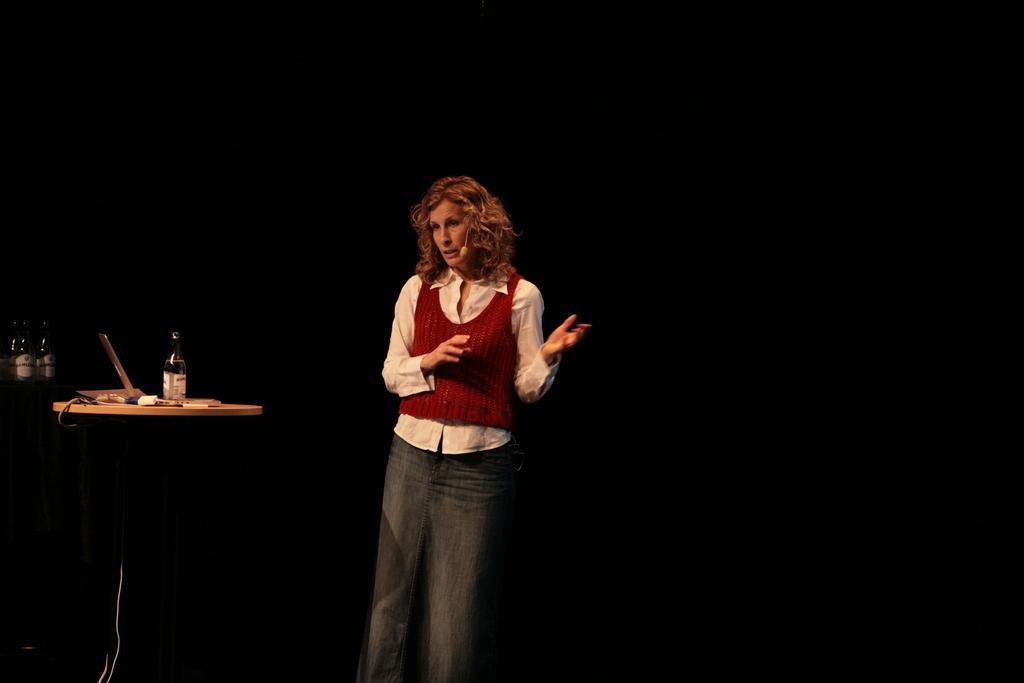How would you summarize this image in a sentence or two? In the picture there is a woman,she is standing and talking something. There is a table beside the woman and on the table there is a laptop,a bottle and some other objects. The background is dark. 